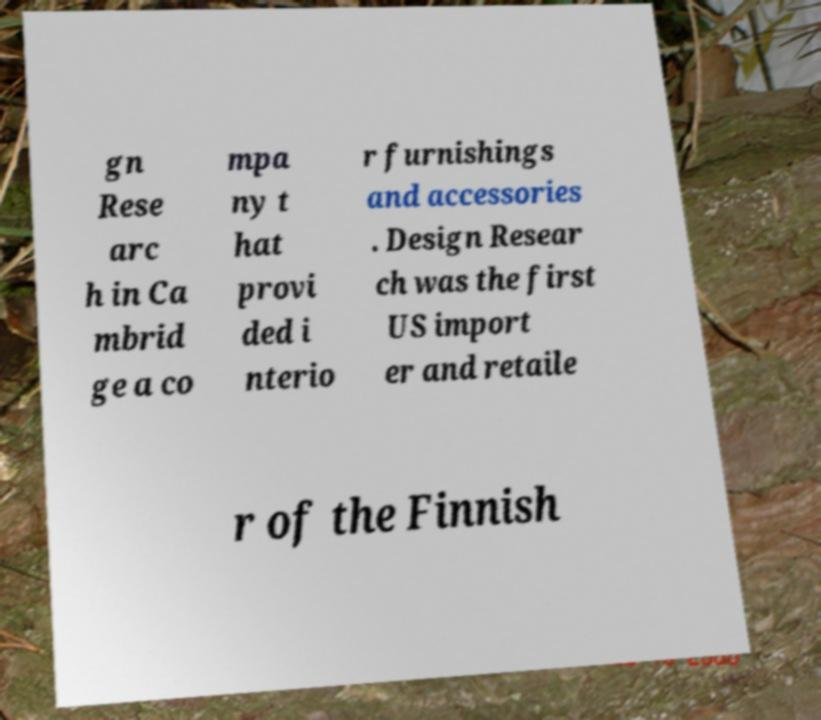I need the written content from this picture converted into text. Can you do that? gn Rese arc h in Ca mbrid ge a co mpa ny t hat provi ded i nterio r furnishings and accessories . Design Resear ch was the first US import er and retaile r of the Finnish 